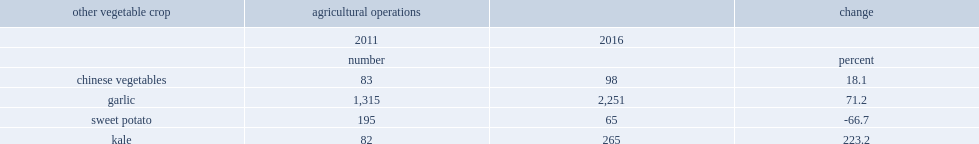How many times does the number of farms reporting kale increase from 2011 to 2016? 3.231707. What is the number of agricultural operations reporting kale in 2011? 82. What is the number of agricultural operations reporting kale in 2016? 265. How much has the number of garlic prducing farms increased? 71.2. What is the total number of garlice producing farms in 2016? 2251. 